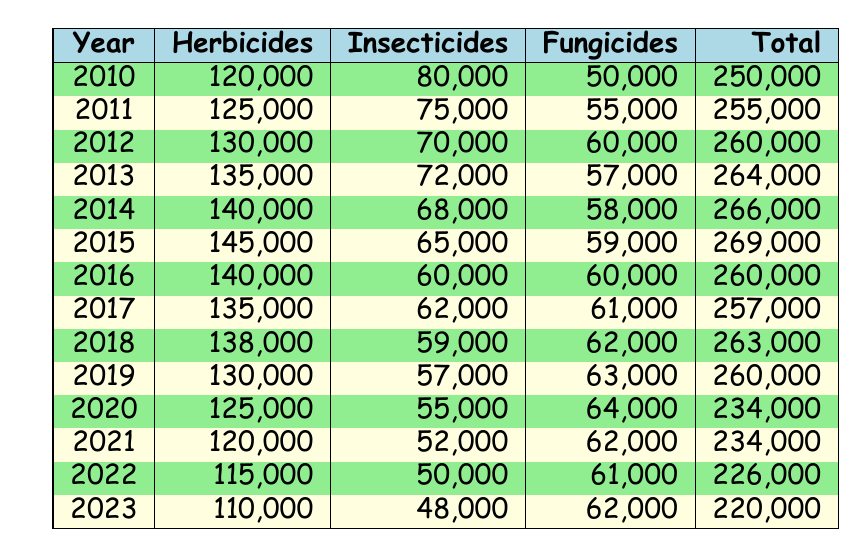What was the total pesticide sales in 2015? The table shows that in 2015, the total pesticide sales were recorded as 269,000.
Answer: 269,000 Which year had the highest insecticide sales? Looking through the insecticide sales column, the year with the highest sales was 2010, with 80,000 sold.
Answer: 2010 What is the average herbicide sales from 2010 to 2023? To calculate the average herbicide sales, we add the herbicide sales from each year: (120,000 + 125,000 + 130,000 + 135,000 + 140,000 + 145,000 + 140,000 + 135,000 + 138,000 + 130,000 + 125,000 + 120,000 + 115,000 + 110,000) = 1,742,000. There are 14 years, so the average is 1,742,000 / 14 = 124,428.57, which rounds to about 124,429.
Answer: 124,429 Did the total pesticide sales increase every year from 2010 to 2015? By examining the total sales figures year-by-year: 250,000 (2010), 255,000 (2011), 260,000 (2012), 264,000 (2013), 266,000 (2014), and 269,000 (2015). Each year shows a consistent increase from 2010 to 2015.
Answer: Yes What is the percentage decrease in total sales from 2020 to 2023? The total sales in 2020 were 234,000 and in 2023, it was 220,000. The decrease is 234,000 - 220,000 = 14,000. To find the percentage decrease, we use the formula: (decrease/original) × 100 = (14,000 / 234,000) × 100, which is approximately 5.98%.
Answer: Approximately 5.98% Which pesticide category had the most consistent yearly sales from 2010 to 2023? By examining the sales of insecticides, they steadily dropped from 80,000 in 2010 to 48,000 in 2023, indicating a consistent trend downward. In contrast, herbicide sales showed fluctuations. Compared to the herbicides, which had some years of rise and fall, the insecticide sales consistently declined each year, making it more consistent overall.
Answer: Insecticides 